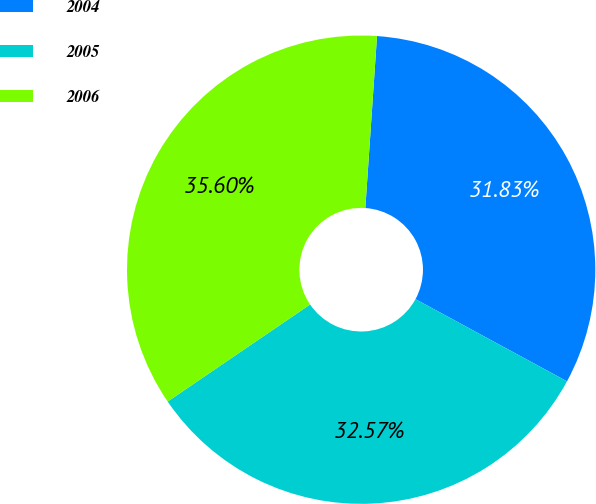Convert chart. <chart><loc_0><loc_0><loc_500><loc_500><pie_chart><fcel>2004<fcel>2005<fcel>2006<nl><fcel>31.83%<fcel>32.57%<fcel>35.6%<nl></chart> 